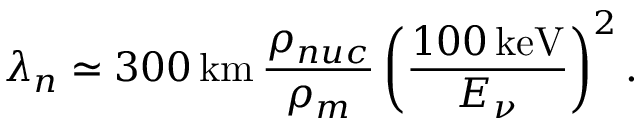<formula> <loc_0><loc_0><loc_500><loc_500>\lambda _ { n } \simeq 3 0 0 \, k m \, \frac { \rho _ { n u c } } { \rho _ { m } } \left ( \frac { 1 0 0 \, k e V } { E _ { \nu } } \right ) ^ { 2 } .</formula> 